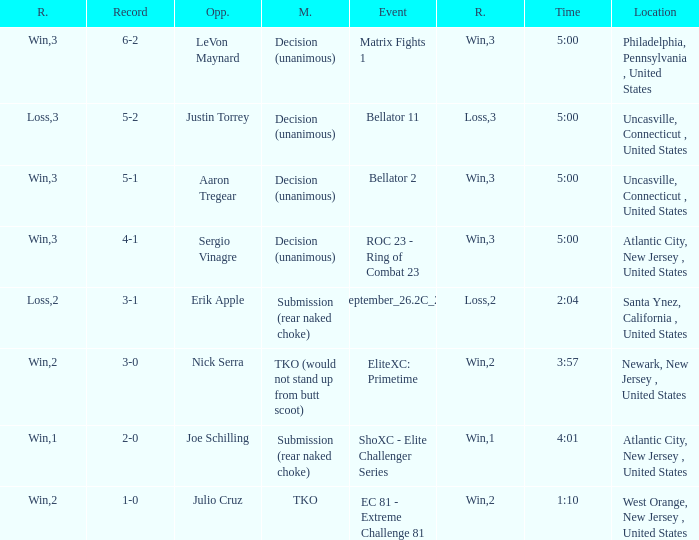What round was it when the method was TKO (would not stand up from Butt Scoot)? 2.0. 